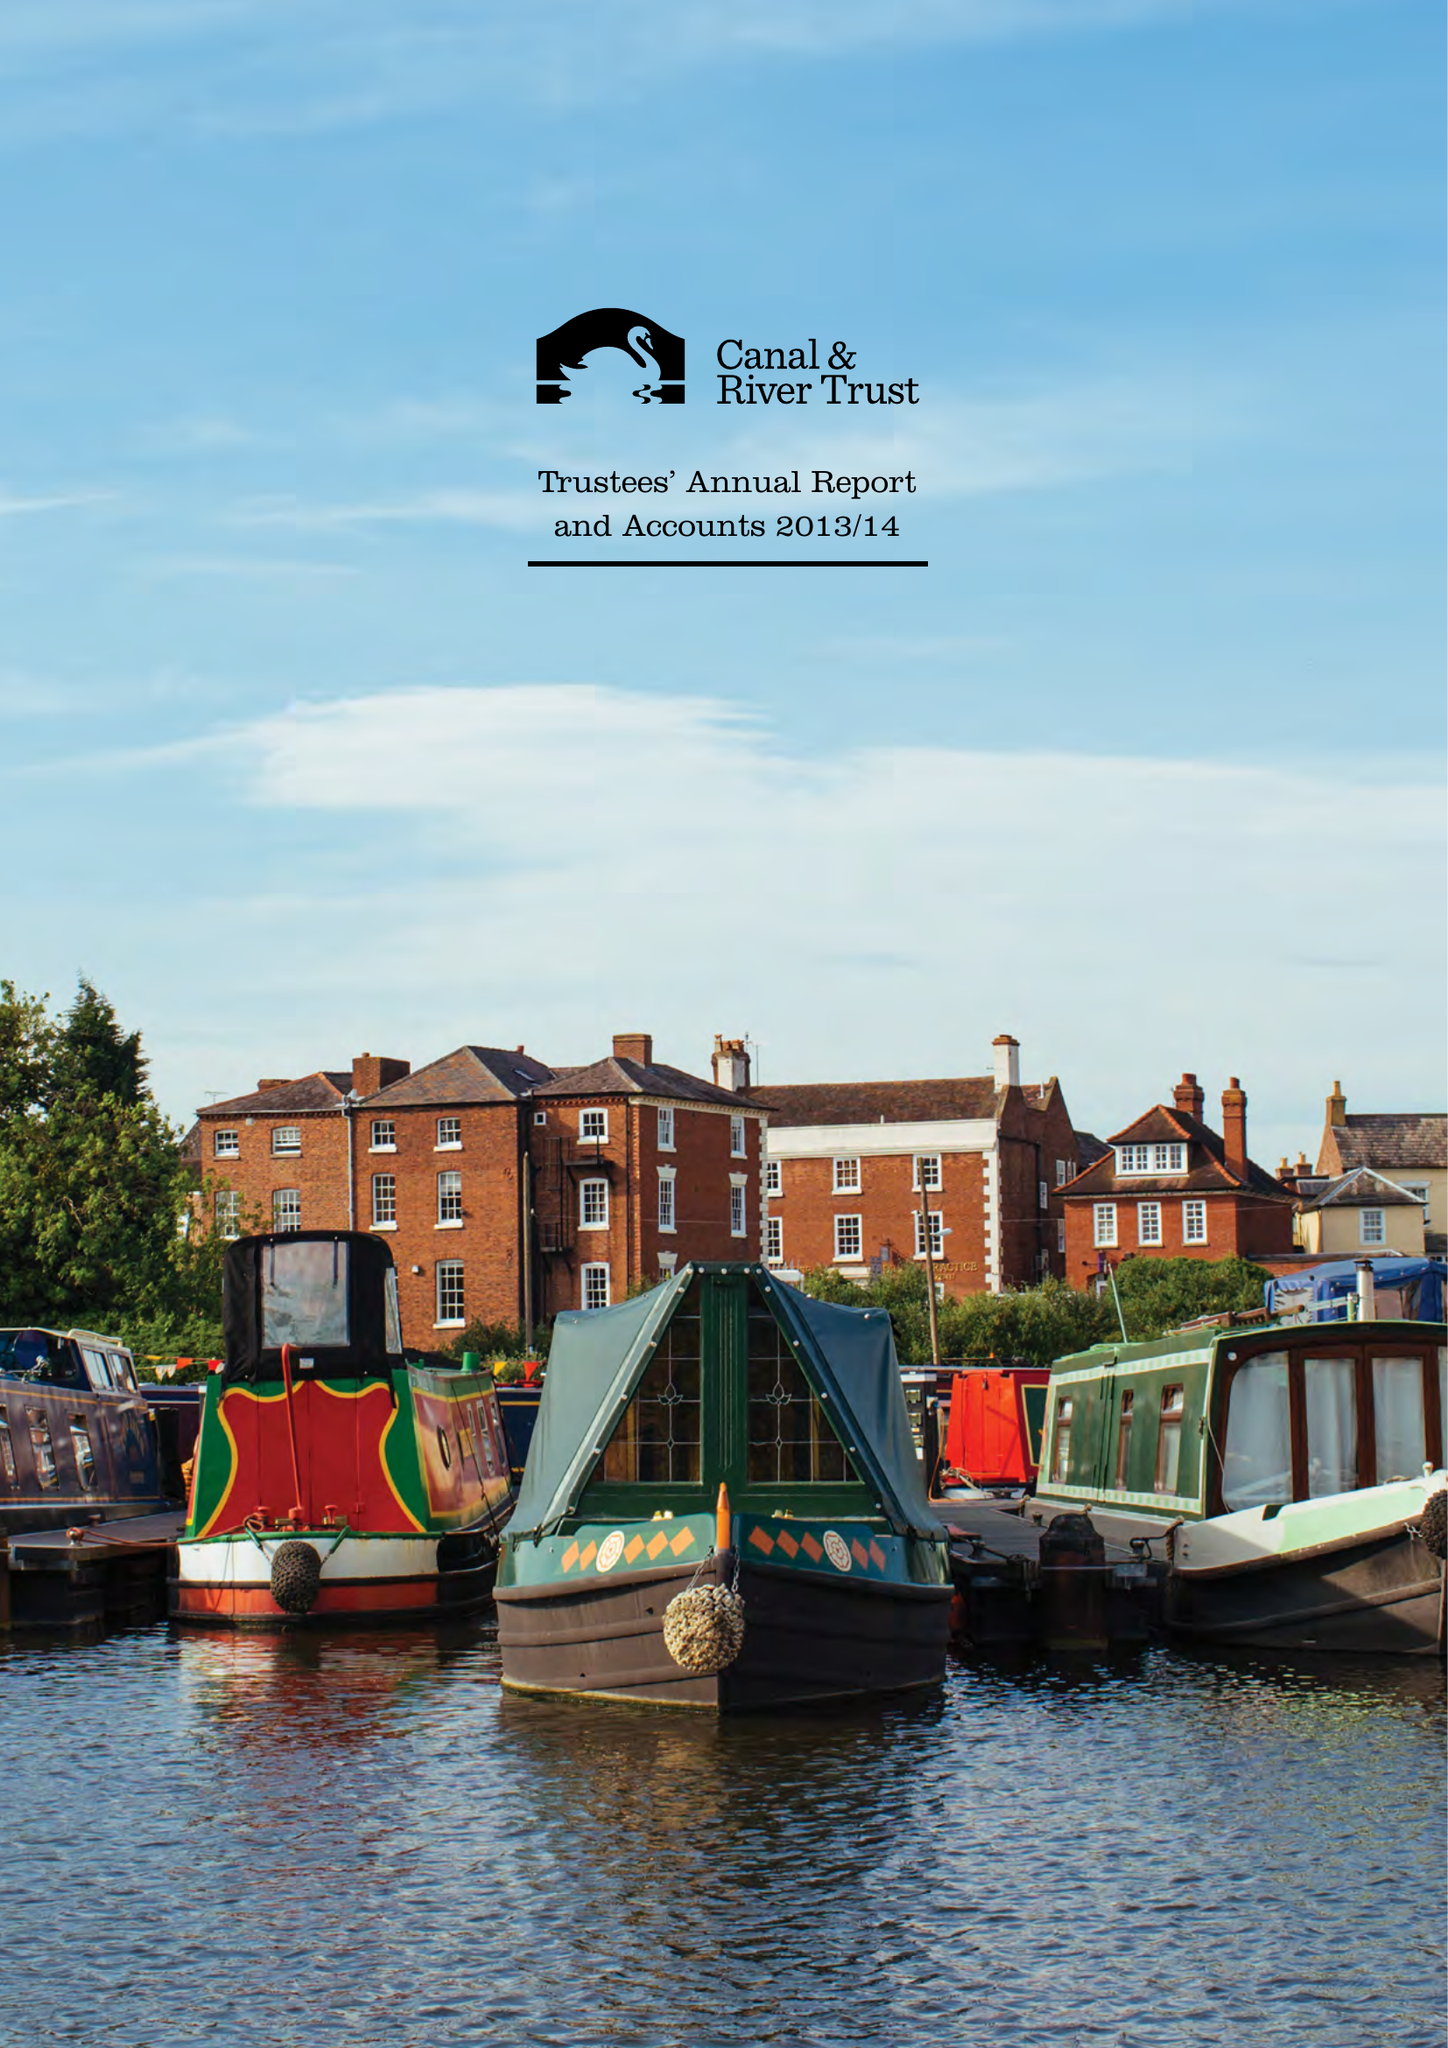What is the value for the address__postcode?
Answer the question using a single word or phrase. MK9 1BB 